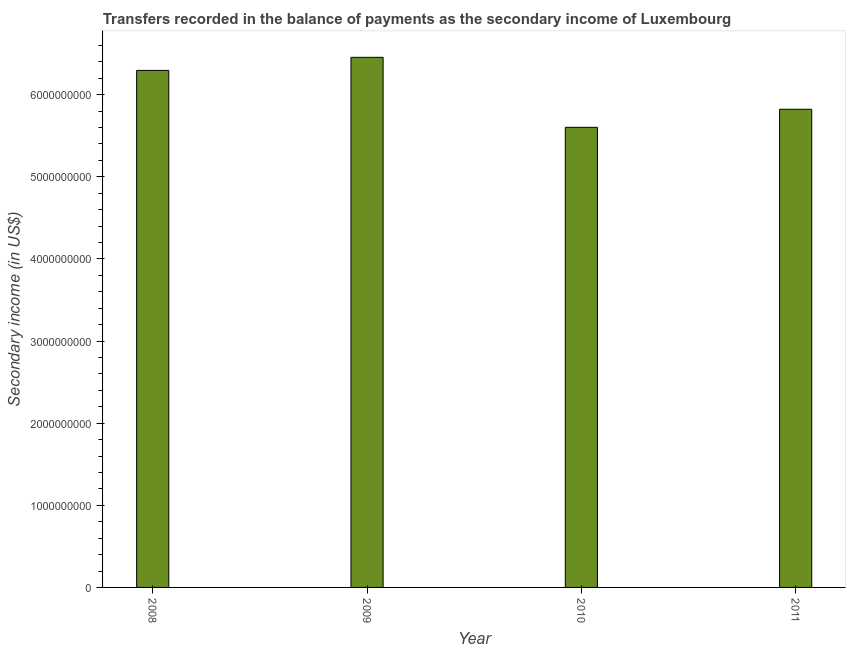What is the title of the graph?
Your answer should be compact. Transfers recorded in the balance of payments as the secondary income of Luxembourg. What is the label or title of the X-axis?
Give a very brief answer. Year. What is the label or title of the Y-axis?
Your answer should be compact. Secondary income (in US$). What is the amount of secondary income in 2009?
Ensure brevity in your answer.  6.45e+09. Across all years, what is the maximum amount of secondary income?
Your response must be concise. 6.45e+09. Across all years, what is the minimum amount of secondary income?
Provide a short and direct response. 5.60e+09. What is the sum of the amount of secondary income?
Offer a very short reply. 2.42e+1. What is the difference between the amount of secondary income in 2008 and 2009?
Make the answer very short. -1.59e+08. What is the average amount of secondary income per year?
Provide a short and direct response. 6.04e+09. What is the median amount of secondary income?
Give a very brief answer. 6.06e+09. In how many years, is the amount of secondary income greater than 6200000000 US$?
Your response must be concise. 2. Do a majority of the years between 2008 and 2009 (inclusive) have amount of secondary income greater than 1200000000 US$?
Ensure brevity in your answer.  Yes. What is the ratio of the amount of secondary income in 2009 to that in 2010?
Your answer should be compact. 1.15. Is the difference between the amount of secondary income in 2010 and 2011 greater than the difference between any two years?
Your answer should be very brief. No. What is the difference between the highest and the second highest amount of secondary income?
Provide a short and direct response. 1.59e+08. Is the sum of the amount of secondary income in 2009 and 2010 greater than the maximum amount of secondary income across all years?
Provide a succinct answer. Yes. What is the difference between the highest and the lowest amount of secondary income?
Your answer should be very brief. 8.52e+08. In how many years, is the amount of secondary income greater than the average amount of secondary income taken over all years?
Your response must be concise. 2. How many bars are there?
Provide a short and direct response. 4. What is the Secondary income (in US$) in 2008?
Provide a succinct answer. 6.30e+09. What is the Secondary income (in US$) in 2009?
Ensure brevity in your answer.  6.45e+09. What is the Secondary income (in US$) in 2010?
Ensure brevity in your answer.  5.60e+09. What is the Secondary income (in US$) in 2011?
Ensure brevity in your answer.  5.82e+09. What is the difference between the Secondary income (in US$) in 2008 and 2009?
Your response must be concise. -1.59e+08. What is the difference between the Secondary income (in US$) in 2008 and 2010?
Your response must be concise. 6.93e+08. What is the difference between the Secondary income (in US$) in 2008 and 2011?
Make the answer very short. 4.73e+08. What is the difference between the Secondary income (in US$) in 2009 and 2010?
Give a very brief answer. 8.52e+08. What is the difference between the Secondary income (in US$) in 2009 and 2011?
Ensure brevity in your answer.  6.33e+08. What is the difference between the Secondary income (in US$) in 2010 and 2011?
Keep it short and to the point. -2.20e+08. What is the ratio of the Secondary income (in US$) in 2008 to that in 2010?
Give a very brief answer. 1.12. What is the ratio of the Secondary income (in US$) in 2008 to that in 2011?
Provide a succinct answer. 1.08. What is the ratio of the Secondary income (in US$) in 2009 to that in 2010?
Ensure brevity in your answer.  1.15. What is the ratio of the Secondary income (in US$) in 2009 to that in 2011?
Your response must be concise. 1.11. What is the ratio of the Secondary income (in US$) in 2010 to that in 2011?
Your response must be concise. 0.96. 